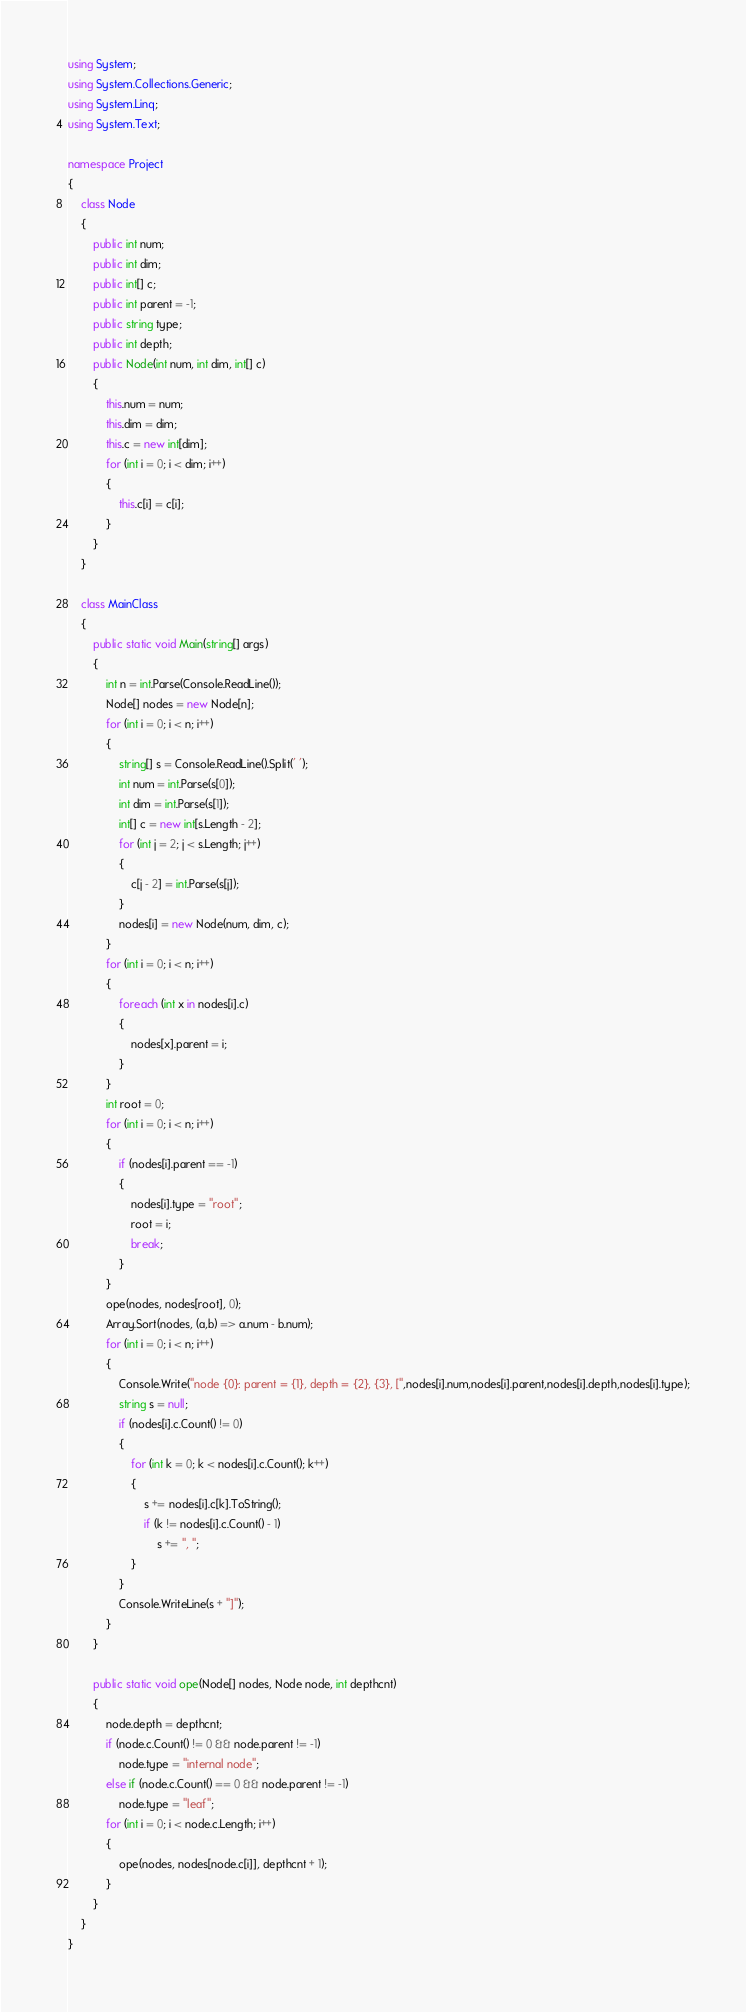Convert code to text. <code><loc_0><loc_0><loc_500><loc_500><_C#_>using System;
using System.Collections.Generic;
using System.Linq;
using System.Text;

namespace Project
{
	class Node
	{
		public int num;
		public int dim;
		public int[] c;
		public int parent = -1;
		public string type;
		public int depth;
		public Node(int num, int dim, int[] c)
		{
			this.num = num;
			this.dim = dim;
			this.c = new int[dim];
			for (int i = 0; i < dim; i++)
			{
				this.c[i] = c[i];
			}
		}
	}

	class MainClass
	{
		public static void Main(string[] args)
		{
			int n = int.Parse(Console.ReadLine());
			Node[] nodes = new Node[n];
			for (int i = 0; i < n; i++)
			{
				string[] s = Console.ReadLine().Split(' ');
				int num = int.Parse(s[0]);
				int dim = int.Parse(s[1]);
				int[] c = new int[s.Length - 2];
				for (int j = 2; j < s.Length; j++)
				{
					c[j - 2] = int.Parse(s[j]);
				}
				nodes[i] = new Node(num, dim, c);
			}
			for (int i = 0; i < n; i++)
			{
				foreach (int x in nodes[i].c)
				{
					nodes[x].parent = i;
				}
			}
			int root = 0;
			for (int i = 0; i < n; i++)
			{
				if (nodes[i].parent == -1)
				{
					nodes[i].type = "root";
					root = i;
					break;
				}
			}
			ope(nodes, nodes[root], 0);
			Array.Sort(nodes, (a,b) => a.num - b.num);
			for (int i = 0; i < n; i++)
			{
				Console.Write("node {0}: parent = {1}, depth = {2}, {3}, [",nodes[i].num,nodes[i].parent,nodes[i].depth,nodes[i].type);
				string s = null;
				if (nodes[i].c.Count() != 0)
				{
					for (int k = 0; k < nodes[i].c.Count(); k++)
					{
						s += nodes[i].c[k].ToString();
						if (k != nodes[i].c.Count() - 1)
							s += ", ";
					}
				}
				Console.WriteLine(s + "]");
			}
		}

		public static void ope(Node[] nodes, Node node, int depthcnt)
		{
			node.depth = depthcnt;
			if (node.c.Count() != 0 && node.parent != -1)
				node.type = "internal node";
			else if (node.c.Count() == 0 && node.parent != -1)
				node.type = "leaf";
			for (int i = 0; i < node.c.Length; i++)
			{
				ope(nodes, nodes[node.c[i]], depthcnt + 1);
			}
		}
	}
}</code> 